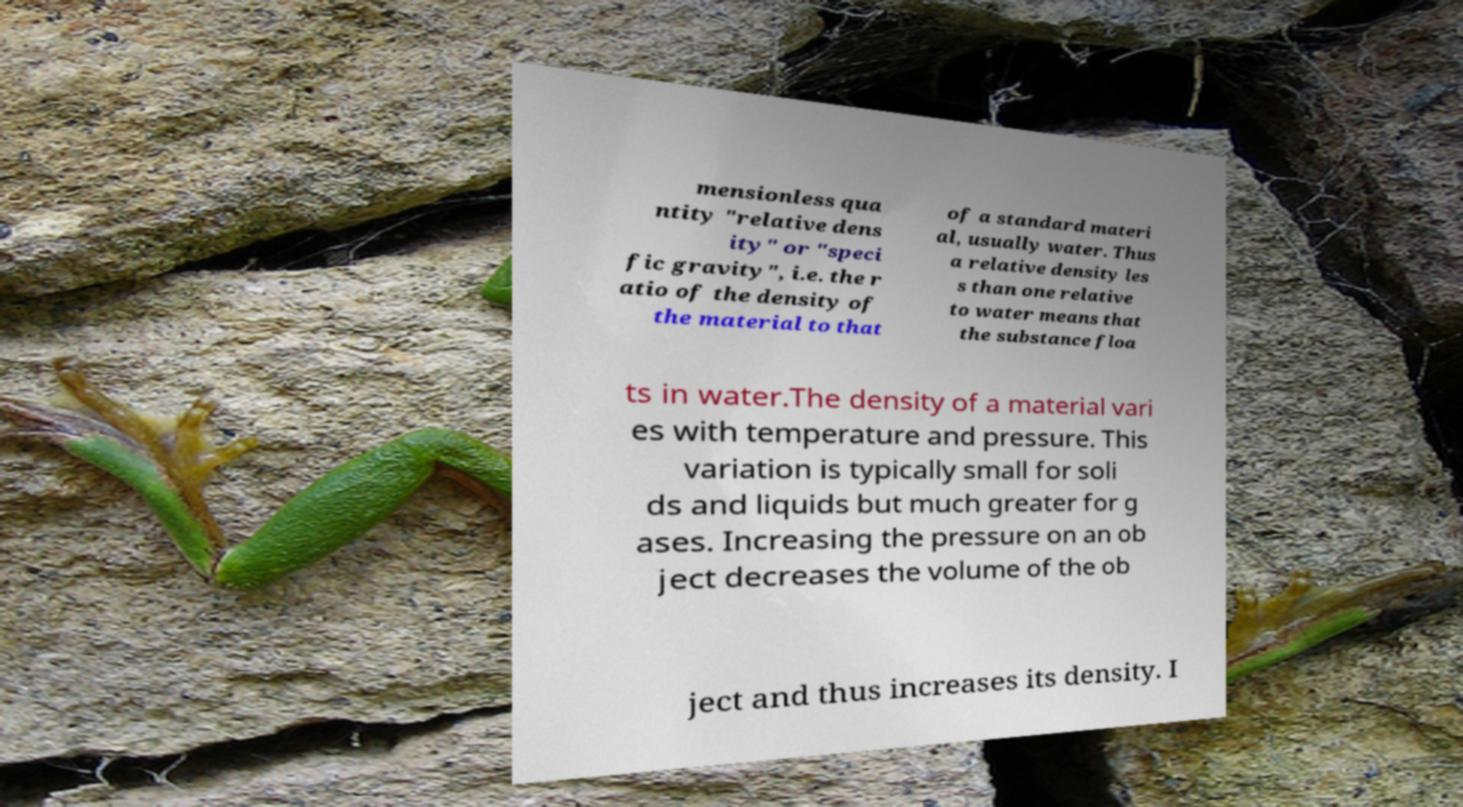Could you assist in decoding the text presented in this image and type it out clearly? mensionless qua ntity "relative dens ity" or "speci fic gravity", i.e. the r atio of the density of the material to that of a standard materi al, usually water. Thus a relative density les s than one relative to water means that the substance floa ts in water.The density of a material vari es with temperature and pressure. This variation is typically small for soli ds and liquids but much greater for g ases. Increasing the pressure on an ob ject decreases the volume of the ob ject and thus increases its density. I 